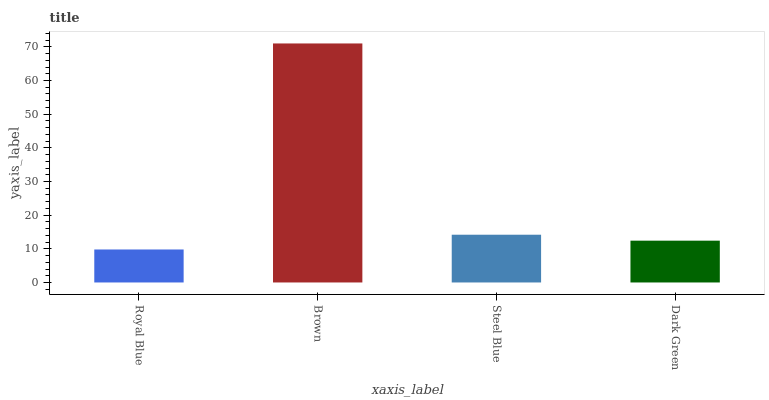Is Royal Blue the minimum?
Answer yes or no. Yes. Is Brown the maximum?
Answer yes or no. Yes. Is Steel Blue the minimum?
Answer yes or no. No. Is Steel Blue the maximum?
Answer yes or no. No. Is Brown greater than Steel Blue?
Answer yes or no. Yes. Is Steel Blue less than Brown?
Answer yes or no. Yes. Is Steel Blue greater than Brown?
Answer yes or no. No. Is Brown less than Steel Blue?
Answer yes or no. No. Is Steel Blue the high median?
Answer yes or no. Yes. Is Dark Green the low median?
Answer yes or no. Yes. Is Brown the high median?
Answer yes or no. No. Is Brown the low median?
Answer yes or no. No. 